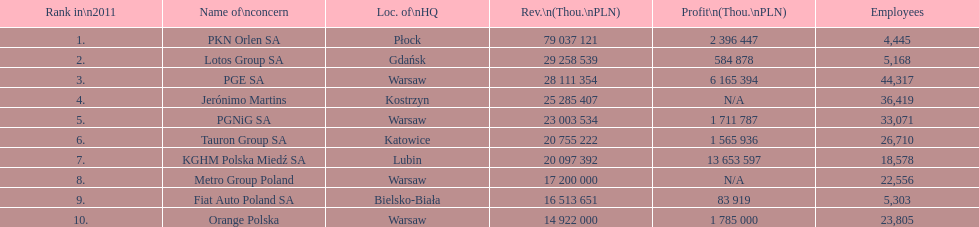How many companies had over $1,000,000 profit? 6. 